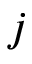<formula> <loc_0><loc_0><loc_500><loc_500>j</formula> 